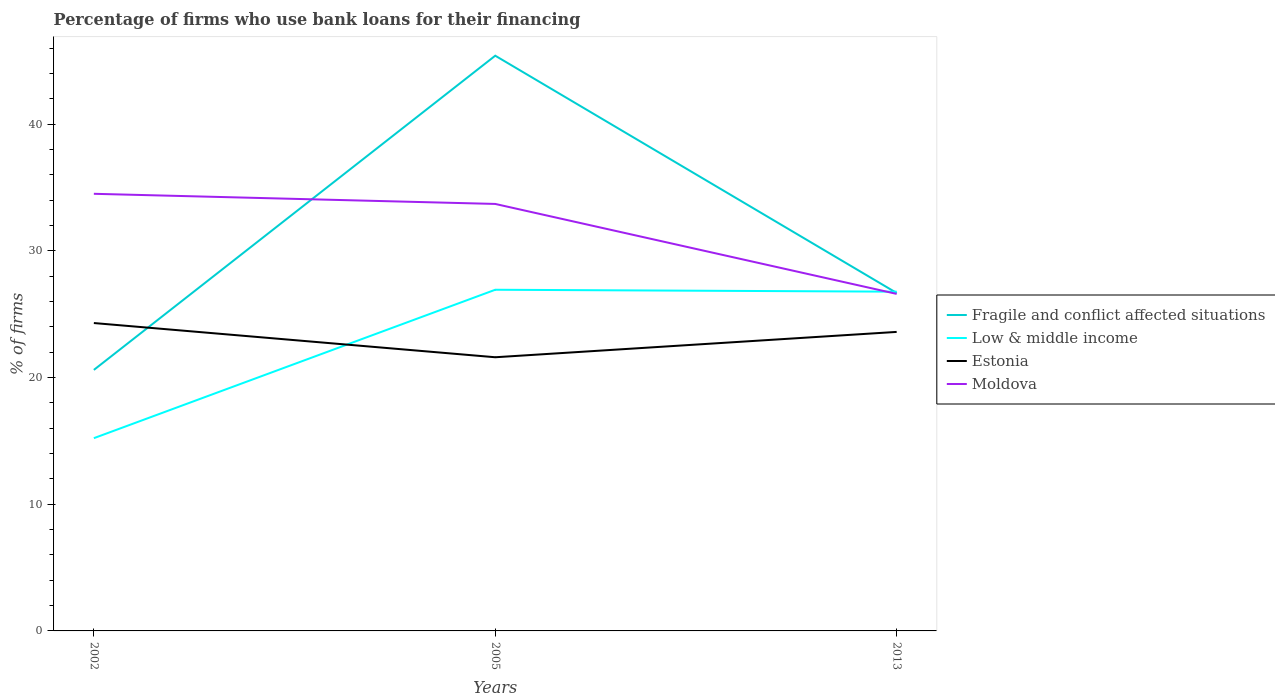Does the line corresponding to Estonia intersect with the line corresponding to Low & middle income?
Provide a succinct answer. Yes. Across all years, what is the maximum percentage of firms who use bank loans for their financing in Fragile and conflict affected situations?
Your answer should be compact. 20.6. In which year was the percentage of firms who use bank loans for their financing in Moldova maximum?
Your answer should be very brief. 2013. What is the total percentage of firms who use bank loans for their financing in Fragile and conflict affected situations in the graph?
Ensure brevity in your answer.  -24.8. What is the difference between the highest and the second highest percentage of firms who use bank loans for their financing in Low & middle income?
Make the answer very short. 11.72. What is the difference between the highest and the lowest percentage of firms who use bank loans for their financing in Estonia?
Offer a terse response. 2. Is the percentage of firms who use bank loans for their financing in Moldova strictly greater than the percentage of firms who use bank loans for their financing in Estonia over the years?
Provide a short and direct response. No. How many lines are there?
Give a very brief answer. 4. How many years are there in the graph?
Keep it short and to the point. 3. Does the graph contain any zero values?
Your answer should be compact. No. Does the graph contain grids?
Provide a short and direct response. No. How are the legend labels stacked?
Your answer should be very brief. Vertical. What is the title of the graph?
Your response must be concise. Percentage of firms who use bank loans for their financing. What is the label or title of the Y-axis?
Provide a succinct answer. % of firms. What is the % of firms in Fragile and conflict affected situations in 2002?
Offer a very short reply. 20.6. What is the % of firms of Low & middle income in 2002?
Make the answer very short. 15.21. What is the % of firms in Estonia in 2002?
Offer a very short reply. 24.3. What is the % of firms of Moldova in 2002?
Offer a very short reply. 34.5. What is the % of firms of Fragile and conflict affected situations in 2005?
Your answer should be very brief. 45.4. What is the % of firms of Low & middle income in 2005?
Ensure brevity in your answer.  26.93. What is the % of firms of Estonia in 2005?
Ensure brevity in your answer.  21.6. What is the % of firms in Moldova in 2005?
Provide a short and direct response. 33.7. What is the % of firms in Fragile and conflict affected situations in 2013?
Provide a succinct answer. 26.67. What is the % of firms in Low & middle income in 2013?
Offer a terse response. 26.78. What is the % of firms in Estonia in 2013?
Offer a terse response. 23.6. What is the % of firms in Moldova in 2013?
Your answer should be compact. 26.6. Across all years, what is the maximum % of firms of Fragile and conflict affected situations?
Provide a short and direct response. 45.4. Across all years, what is the maximum % of firms in Low & middle income?
Your answer should be very brief. 26.93. Across all years, what is the maximum % of firms of Estonia?
Your response must be concise. 24.3. Across all years, what is the maximum % of firms in Moldova?
Keep it short and to the point. 34.5. Across all years, what is the minimum % of firms in Fragile and conflict affected situations?
Offer a terse response. 20.6. Across all years, what is the minimum % of firms of Low & middle income?
Keep it short and to the point. 15.21. Across all years, what is the minimum % of firms of Estonia?
Ensure brevity in your answer.  21.6. Across all years, what is the minimum % of firms of Moldova?
Provide a short and direct response. 26.6. What is the total % of firms in Fragile and conflict affected situations in the graph?
Keep it short and to the point. 92.67. What is the total % of firms of Low & middle income in the graph?
Offer a very short reply. 68.92. What is the total % of firms in Estonia in the graph?
Give a very brief answer. 69.5. What is the total % of firms in Moldova in the graph?
Your answer should be compact. 94.8. What is the difference between the % of firms of Fragile and conflict affected situations in 2002 and that in 2005?
Keep it short and to the point. -24.8. What is the difference between the % of firms of Low & middle income in 2002 and that in 2005?
Keep it short and to the point. -11.72. What is the difference between the % of firms in Estonia in 2002 and that in 2005?
Ensure brevity in your answer.  2.7. What is the difference between the % of firms of Fragile and conflict affected situations in 2002 and that in 2013?
Offer a very short reply. -6.07. What is the difference between the % of firms in Low & middle income in 2002 and that in 2013?
Provide a short and direct response. -11.56. What is the difference between the % of firms of Fragile and conflict affected situations in 2005 and that in 2013?
Give a very brief answer. 18.73. What is the difference between the % of firms of Low & middle income in 2005 and that in 2013?
Keep it short and to the point. 0.15. What is the difference between the % of firms of Estonia in 2005 and that in 2013?
Your response must be concise. -2. What is the difference between the % of firms in Moldova in 2005 and that in 2013?
Ensure brevity in your answer.  7.1. What is the difference between the % of firms of Fragile and conflict affected situations in 2002 and the % of firms of Low & middle income in 2005?
Your answer should be very brief. -6.33. What is the difference between the % of firms of Low & middle income in 2002 and the % of firms of Estonia in 2005?
Keep it short and to the point. -6.39. What is the difference between the % of firms of Low & middle income in 2002 and the % of firms of Moldova in 2005?
Your response must be concise. -18.49. What is the difference between the % of firms of Estonia in 2002 and the % of firms of Moldova in 2005?
Offer a terse response. -9.4. What is the difference between the % of firms in Fragile and conflict affected situations in 2002 and the % of firms in Low & middle income in 2013?
Your answer should be compact. -6.18. What is the difference between the % of firms in Fragile and conflict affected situations in 2002 and the % of firms in Estonia in 2013?
Keep it short and to the point. -3. What is the difference between the % of firms of Low & middle income in 2002 and the % of firms of Estonia in 2013?
Your answer should be compact. -8.39. What is the difference between the % of firms in Low & middle income in 2002 and the % of firms in Moldova in 2013?
Ensure brevity in your answer.  -11.39. What is the difference between the % of firms of Estonia in 2002 and the % of firms of Moldova in 2013?
Your response must be concise. -2.3. What is the difference between the % of firms of Fragile and conflict affected situations in 2005 and the % of firms of Low & middle income in 2013?
Keep it short and to the point. 18.62. What is the difference between the % of firms of Fragile and conflict affected situations in 2005 and the % of firms of Estonia in 2013?
Offer a very short reply. 21.8. What is the difference between the % of firms of Low & middle income in 2005 and the % of firms of Estonia in 2013?
Your response must be concise. 3.33. What is the difference between the % of firms in Low & middle income in 2005 and the % of firms in Moldova in 2013?
Provide a short and direct response. 0.33. What is the difference between the % of firms of Estonia in 2005 and the % of firms of Moldova in 2013?
Your answer should be very brief. -5. What is the average % of firms of Fragile and conflict affected situations per year?
Give a very brief answer. 30.89. What is the average % of firms of Low & middle income per year?
Offer a very short reply. 22.97. What is the average % of firms of Estonia per year?
Give a very brief answer. 23.17. What is the average % of firms of Moldova per year?
Your answer should be compact. 31.6. In the year 2002, what is the difference between the % of firms in Fragile and conflict affected situations and % of firms in Low & middle income?
Offer a terse response. 5.39. In the year 2002, what is the difference between the % of firms of Fragile and conflict affected situations and % of firms of Estonia?
Your answer should be very brief. -3.7. In the year 2002, what is the difference between the % of firms of Low & middle income and % of firms of Estonia?
Give a very brief answer. -9.09. In the year 2002, what is the difference between the % of firms of Low & middle income and % of firms of Moldova?
Make the answer very short. -19.29. In the year 2005, what is the difference between the % of firms in Fragile and conflict affected situations and % of firms in Low & middle income?
Make the answer very short. 18.47. In the year 2005, what is the difference between the % of firms of Fragile and conflict affected situations and % of firms of Estonia?
Give a very brief answer. 23.8. In the year 2005, what is the difference between the % of firms in Fragile and conflict affected situations and % of firms in Moldova?
Your response must be concise. 11.7. In the year 2005, what is the difference between the % of firms of Low & middle income and % of firms of Estonia?
Your answer should be very brief. 5.33. In the year 2005, what is the difference between the % of firms of Low & middle income and % of firms of Moldova?
Provide a short and direct response. -6.77. In the year 2013, what is the difference between the % of firms of Fragile and conflict affected situations and % of firms of Low & middle income?
Ensure brevity in your answer.  -0.1. In the year 2013, what is the difference between the % of firms of Fragile and conflict affected situations and % of firms of Estonia?
Your response must be concise. 3.07. In the year 2013, what is the difference between the % of firms in Fragile and conflict affected situations and % of firms in Moldova?
Keep it short and to the point. 0.07. In the year 2013, what is the difference between the % of firms of Low & middle income and % of firms of Estonia?
Offer a very short reply. 3.18. In the year 2013, what is the difference between the % of firms in Low & middle income and % of firms in Moldova?
Your answer should be compact. 0.18. What is the ratio of the % of firms of Fragile and conflict affected situations in 2002 to that in 2005?
Your answer should be compact. 0.45. What is the ratio of the % of firms in Low & middle income in 2002 to that in 2005?
Give a very brief answer. 0.56. What is the ratio of the % of firms in Estonia in 2002 to that in 2005?
Provide a short and direct response. 1.12. What is the ratio of the % of firms of Moldova in 2002 to that in 2005?
Offer a terse response. 1.02. What is the ratio of the % of firms of Fragile and conflict affected situations in 2002 to that in 2013?
Ensure brevity in your answer.  0.77. What is the ratio of the % of firms in Low & middle income in 2002 to that in 2013?
Your response must be concise. 0.57. What is the ratio of the % of firms in Estonia in 2002 to that in 2013?
Offer a very short reply. 1.03. What is the ratio of the % of firms in Moldova in 2002 to that in 2013?
Provide a succinct answer. 1.3. What is the ratio of the % of firms of Fragile and conflict affected situations in 2005 to that in 2013?
Give a very brief answer. 1.7. What is the ratio of the % of firms in Estonia in 2005 to that in 2013?
Keep it short and to the point. 0.92. What is the ratio of the % of firms of Moldova in 2005 to that in 2013?
Give a very brief answer. 1.27. What is the difference between the highest and the second highest % of firms of Fragile and conflict affected situations?
Offer a terse response. 18.73. What is the difference between the highest and the second highest % of firms in Low & middle income?
Your answer should be compact. 0.15. What is the difference between the highest and the second highest % of firms of Moldova?
Your answer should be compact. 0.8. What is the difference between the highest and the lowest % of firms of Fragile and conflict affected situations?
Provide a succinct answer. 24.8. What is the difference between the highest and the lowest % of firms of Low & middle income?
Keep it short and to the point. 11.72. 